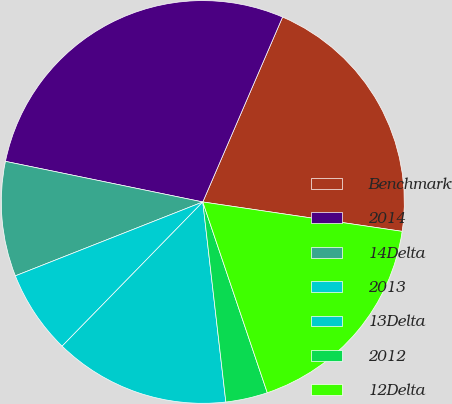Convert chart to OTSL. <chart><loc_0><loc_0><loc_500><loc_500><pie_chart><fcel>Benchmark<fcel>2014<fcel>14Delta<fcel>2013<fcel>13Delta<fcel>2012<fcel>12Delta<nl><fcel>20.85%<fcel>28.24%<fcel>9.21%<fcel>6.72%<fcel>14.12%<fcel>3.36%<fcel>17.48%<nl></chart> 